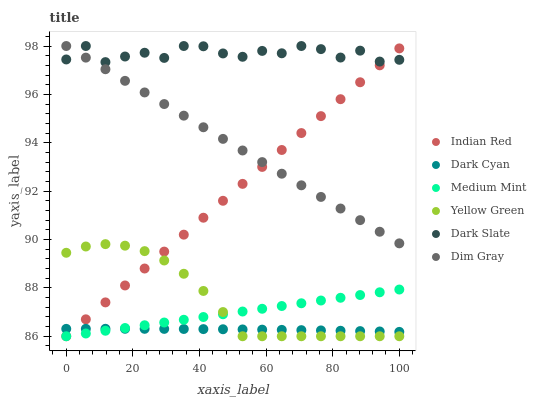Does Dark Cyan have the minimum area under the curve?
Answer yes or no. Yes. Does Dark Slate have the maximum area under the curve?
Answer yes or no. Yes. Does Dim Gray have the minimum area under the curve?
Answer yes or no. No. Does Dim Gray have the maximum area under the curve?
Answer yes or no. No. Is Dim Gray the smoothest?
Answer yes or no. Yes. Is Dark Slate the roughest?
Answer yes or no. Yes. Is Yellow Green the smoothest?
Answer yes or no. No. Is Yellow Green the roughest?
Answer yes or no. No. Does Medium Mint have the lowest value?
Answer yes or no. Yes. Does Dim Gray have the lowest value?
Answer yes or no. No. Does Dark Slate have the highest value?
Answer yes or no. Yes. Does Yellow Green have the highest value?
Answer yes or no. No. Is Dark Cyan less than Dark Slate?
Answer yes or no. Yes. Is Dim Gray greater than Yellow Green?
Answer yes or no. Yes. Does Medium Mint intersect Dark Cyan?
Answer yes or no. Yes. Is Medium Mint less than Dark Cyan?
Answer yes or no. No. Is Medium Mint greater than Dark Cyan?
Answer yes or no. No. Does Dark Cyan intersect Dark Slate?
Answer yes or no. No. 